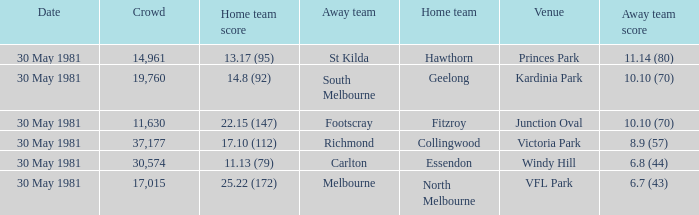What is the home venue of essendon with a crowd larger than 19,760? Windy Hill. 